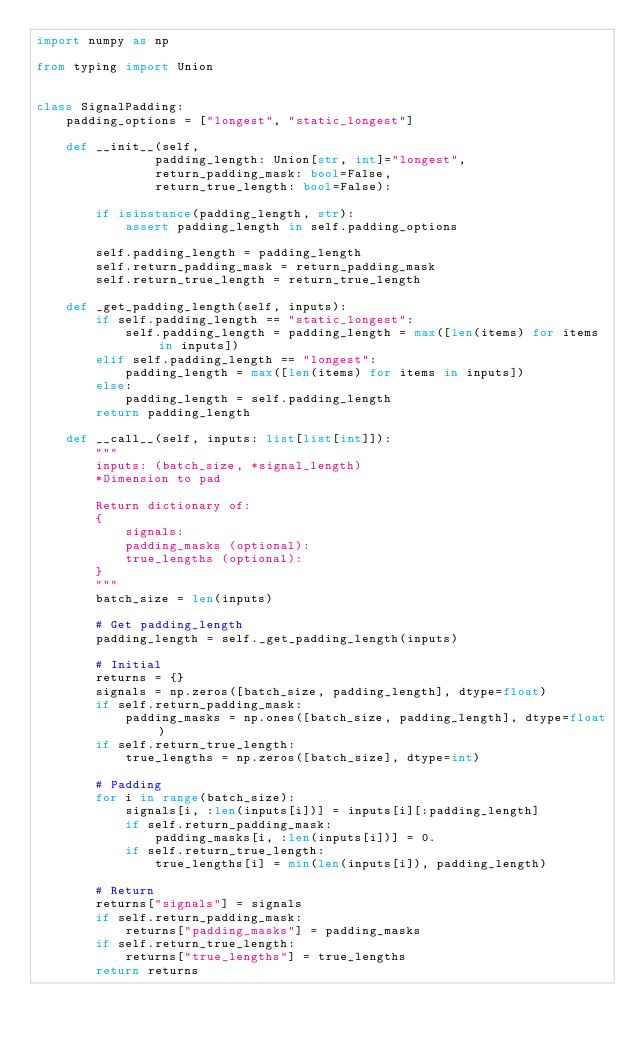Convert code to text. <code><loc_0><loc_0><loc_500><loc_500><_Python_>import numpy as np

from typing import Union


class SignalPadding:
    padding_options = ["longest", "static_longest"]

    def __init__(self,
                padding_length: Union[str, int]="longest",
                return_padding_mask: bool=False,
                return_true_length: bool=False):

        if isinstance(padding_length, str):
            assert padding_length in self.padding_options

        self.padding_length = padding_length
        self.return_padding_mask = return_padding_mask
        self.return_true_length = return_true_length

    def _get_padding_length(self, inputs):
        if self.padding_length == "static_longest":
            self.padding_length = padding_length = max([len(items) for items in inputs])
        elif self.padding_length == "longest":
            padding_length = max([len(items) for items in inputs])
        else:
            padding_length = self.padding_length
        return padding_length

    def __call__(self, inputs: list[list[int]]):
        """
        inputs: (batch_size, *signal_length)
        *Dimension to pad

        Return dictionary of:
        {
            signals:
            padding_masks (optional):
            true_lengths (optional):
        }
        """
        batch_size = len(inputs)

        # Get padding_length
        padding_length = self._get_padding_length(inputs)

        # Initial
        returns = {}
        signals = np.zeros([batch_size, padding_length], dtype=float)
        if self.return_padding_mask:
            padding_masks = np.ones([batch_size, padding_length], dtype=float)
        if self.return_true_length:
            true_lengths = np.zeros([batch_size], dtype=int)

        # Padding
        for i in range(batch_size):
            signals[i, :len(inputs[i])] = inputs[i][:padding_length]
            if self.return_padding_mask:
                padding_masks[i, :len(inputs[i])] = 0.
            if self.return_true_length:
                true_lengths[i] = min(len(inputs[i]), padding_length)

        # Return
        returns["signals"] = signals
        if self.return_padding_mask:
            returns["padding_masks"] = padding_masks
        if self.return_true_length:
            returns["true_lengths"] = true_lengths
        return returns
</code> 